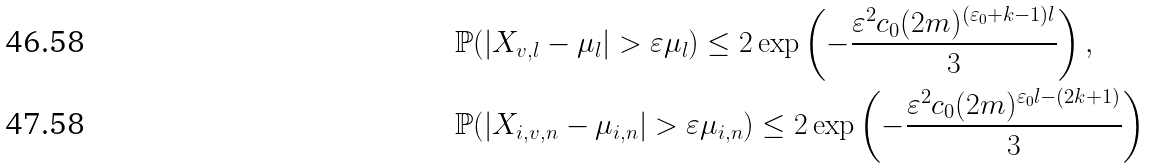<formula> <loc_0><loc_0><loc_500><loc_500>& \mathbb { P } ( | X _ { v , l } - \mu _ { l } | > \varepsilon \mu _ { l } ) \leq 2 \exp \left ( - \frac { \varepsilon ^ { 2 } c _ { 0 } ( 2 m ) ^ { ( \varepsilon _ { 0 } + k - 1 ) l } } { 3 } \right ) , \\ & \mathbb { P } ( | X _ { i , v , n } - \mu _ { i , n } | > \varepsilon \mu _ { i , n } ) \leq 2 \exp \left ( - \frac { \varepsilon ^ { 2 } c _ { 0 } ( 2 m ) ^ { \varepsilon _ { 0 } l - ( 2 k + 1 ) } } { 3 } \right )</formula> 